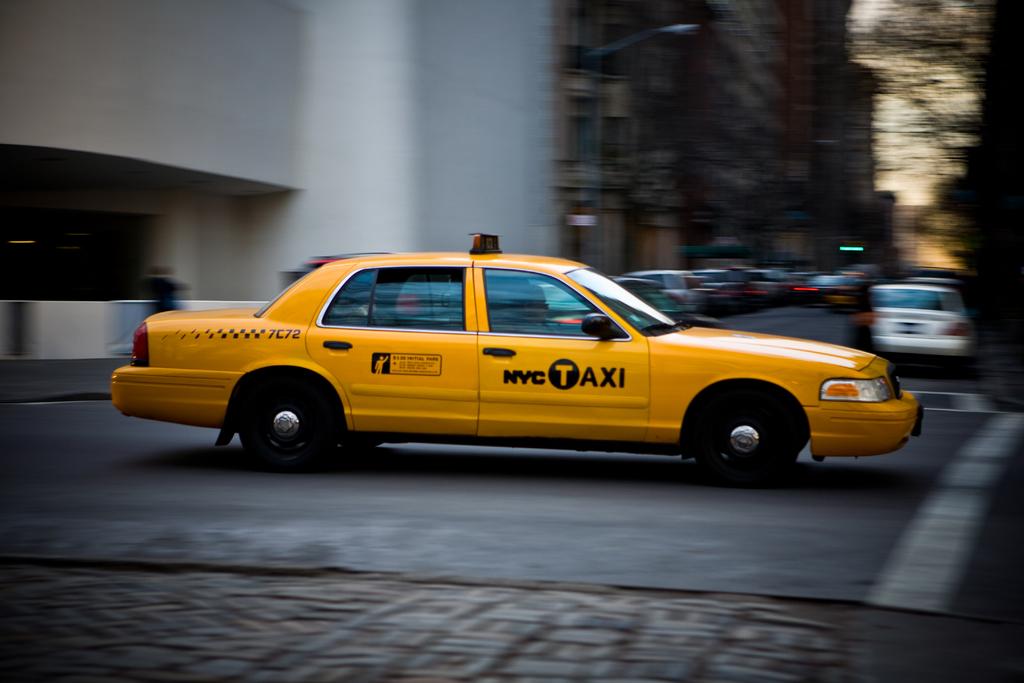What city does the taxi work in?
Offer a terse response. Nyc. What taxi is this?
Provide a succinct answer. Nyc. 